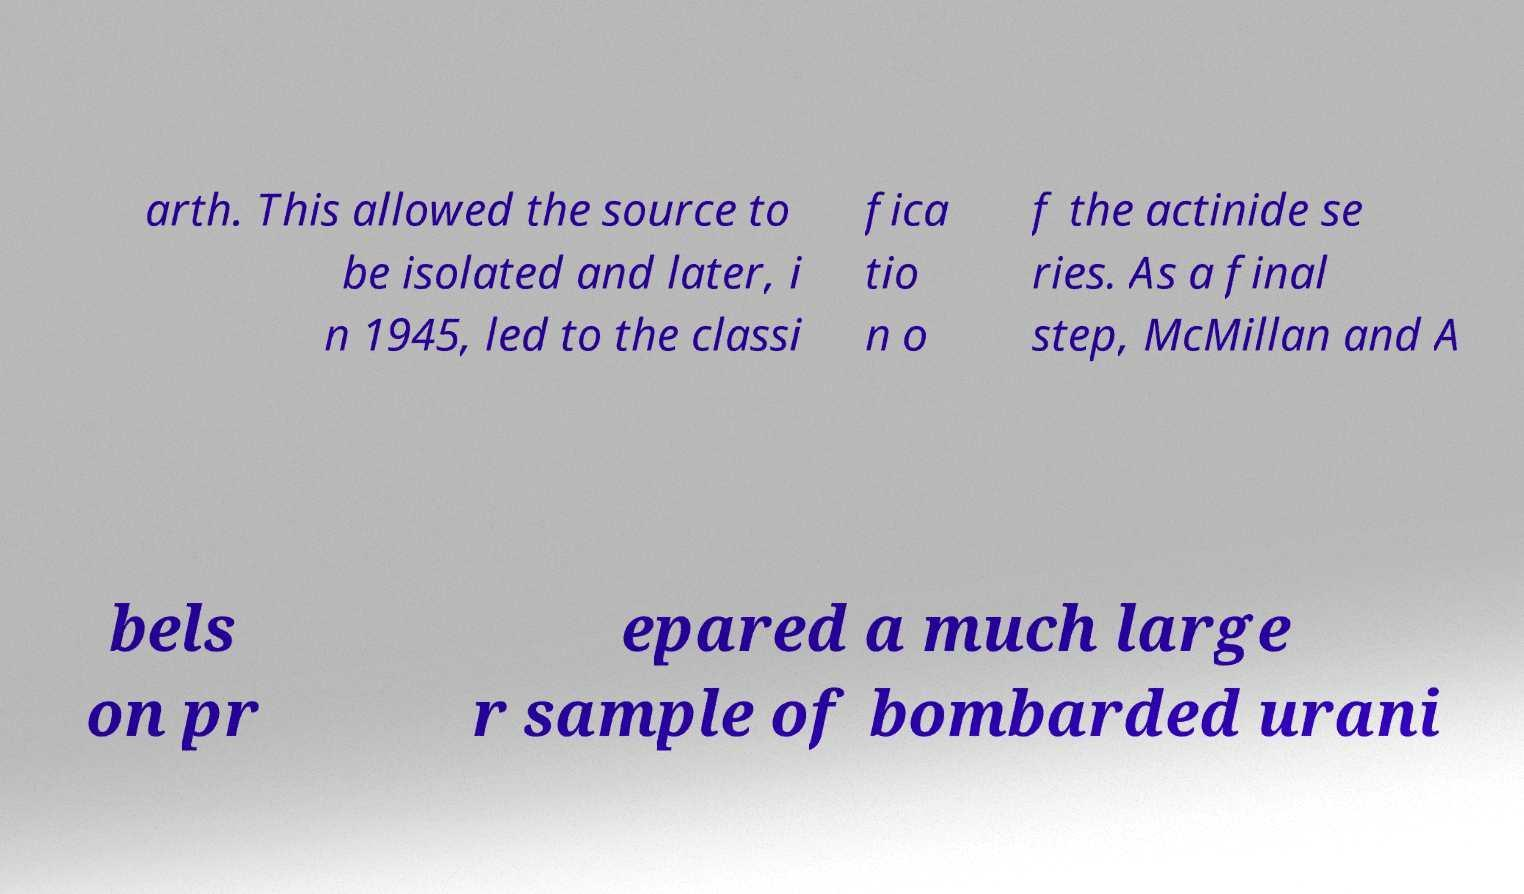Please identify and transcribe the text found in this image. arth. This allowed the source to be isolated and later, i n 1945, led to the classi fica tio n o f the actinide se ries. As a final step, McMillan and A bels on pr epared a much large r sample of bombarded urani 